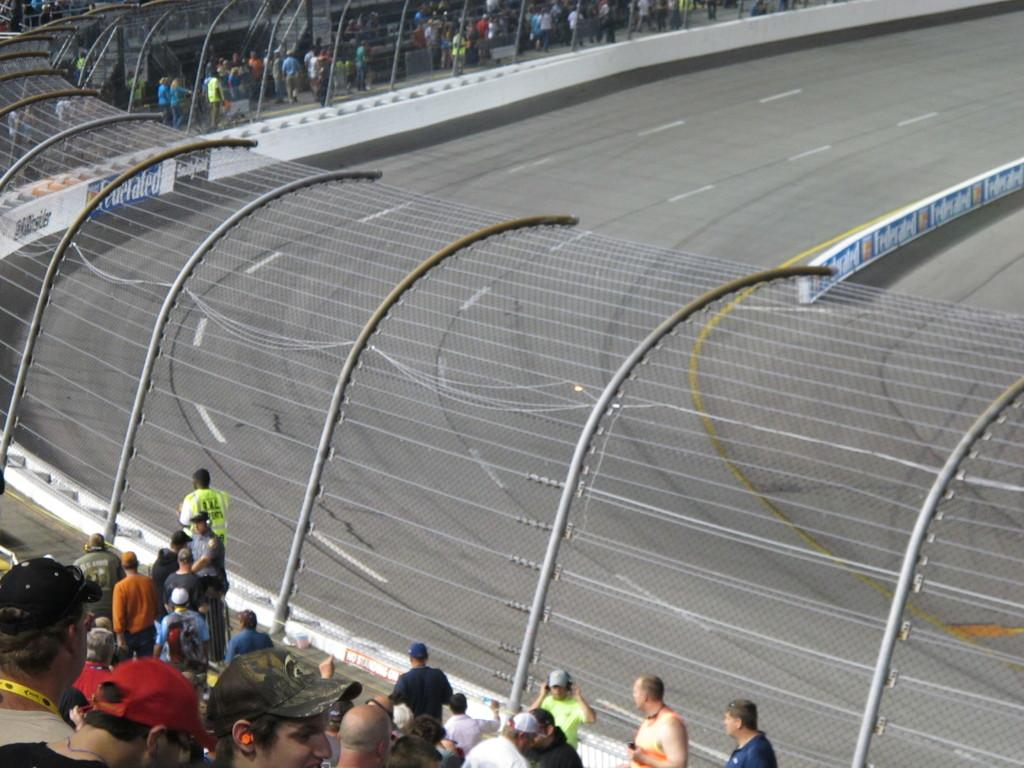How many people are in the image? There is a group of people in the image, but the exact number is not specified. What are some of the people in the image doing? Some people are standing in the image. What type of surface can be seen in the image? There is a road in the image. What is the purpose of the fence in the image? The purpose of the fence is not specified, but it is present in the image. What can be seen on the road in the image? White lines are visible on the road. What type of collar can be seen on the music in the image? There is no music or collar present in the image. 